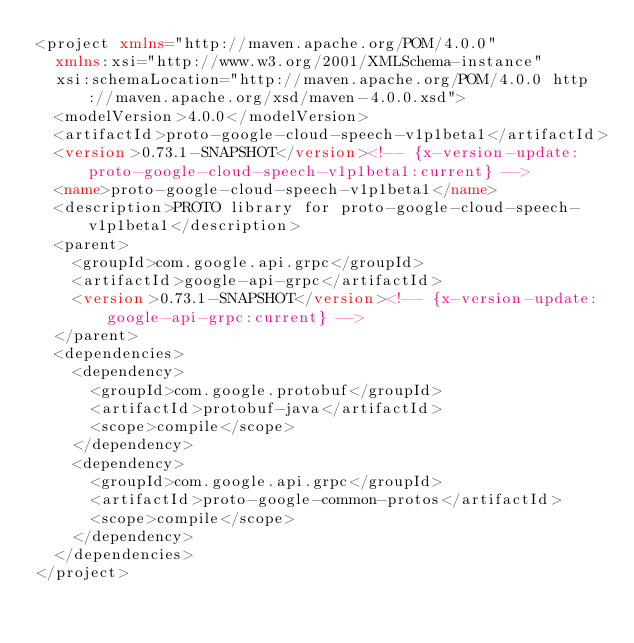<code> <loc_0><loc_0><loc_500><loc_500><_XML_><project xmlns="http://maven.apache.org/POM/4.0.0"
  xmlns:xsi="http://www.w3.org/2001/XMLSchema-instance"
  xsi:schemaLocation="http://maven.apache.org/POM/4.0.0 http://maven.apache.org/xsd/maven-4.0.0.xsd">
  <modelVersion>4.0.0</modelVersion>
  <artifactId>proto-google-cloud-speech-v1p1beta1</artifactId>
  <version>0.73.1-SNAPSHOT</version><!-- {x-version-update:proto-google-cloud-speech-v1p1beta1:current} -->
  <name>proto-google-cloud-speech-v1p1beta1</name>
  <description>PROTO library for proto-google-cloud-speech-v1p1beta1</description>
  <parent>
    <groupId>com.google.api.grpc</groupId>
    <artifactId>google-api-grpc</artifactId>
    <version>0.73.1-SNAPSHOT</version><!-- {x-version-update:google-api-grpc:current} -->
  </parent>
  <dependencies>
    <dependency>
      <groupId>com.google.protobuf</groupId>
      <artifactId>protobuf-java</artifactId>
      <scope>compile</scope>
    </dependency>
    <dependency>
      <groupId>com.google.api.grpc</groupId>
      <artifactId>proto-google-common-protos</artifactId>
      <scope>compile</scope>
    </dependency>
  </dependencies>
</project></code> 